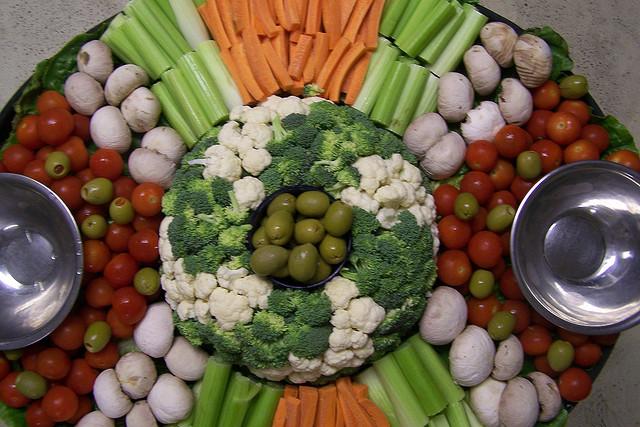What number of veggies are on this platter?
Quick response, please. 7. What color are the olives?
Be succinct. Green. Would a vegetarian eat this dish?
Be succinct. Yes. Are these ingredients for a juice?
Concise answer only. No. 